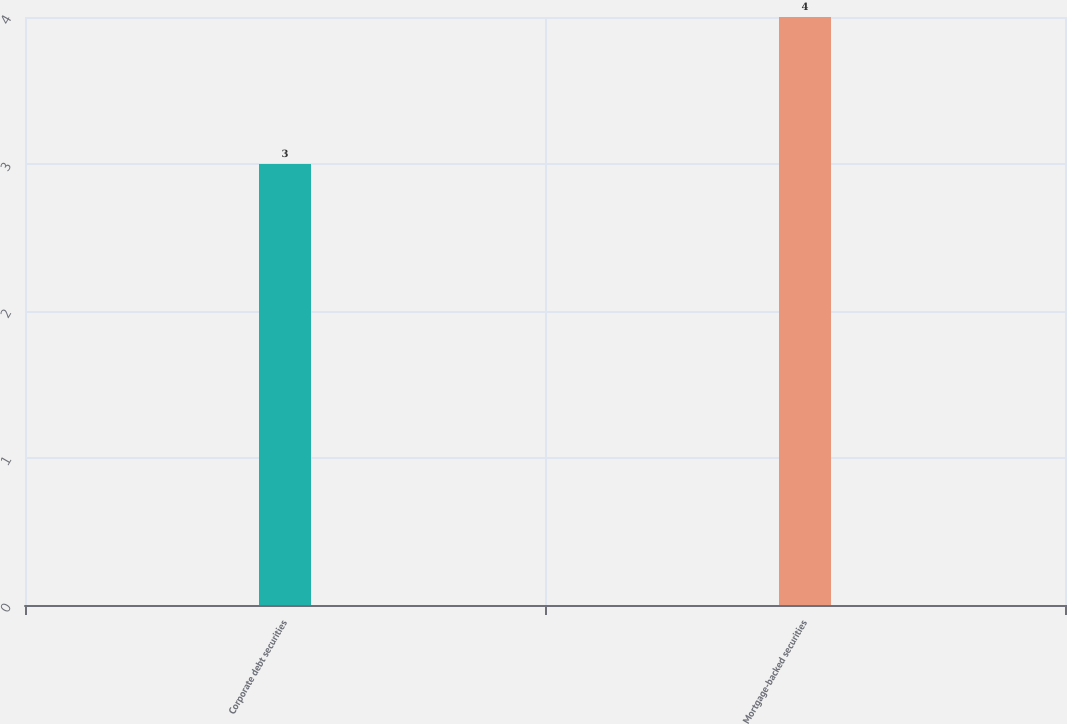Convert chart to OTSL. <chart><loc_0><loc_0><loc_500><loc_500><bar_chart><fcel>Corporate debt securities<fcel>Mortgage-backed securities<nl><fcel>3<fcel>4<nl></chart> 